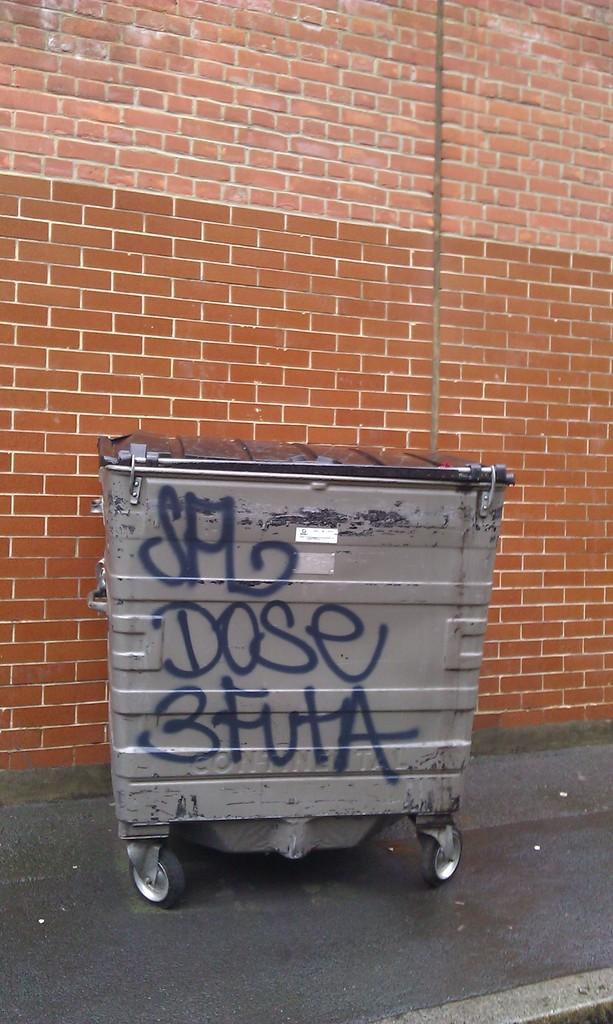What is the only number on the garbage can?
Keep it short and to the point. 3. 